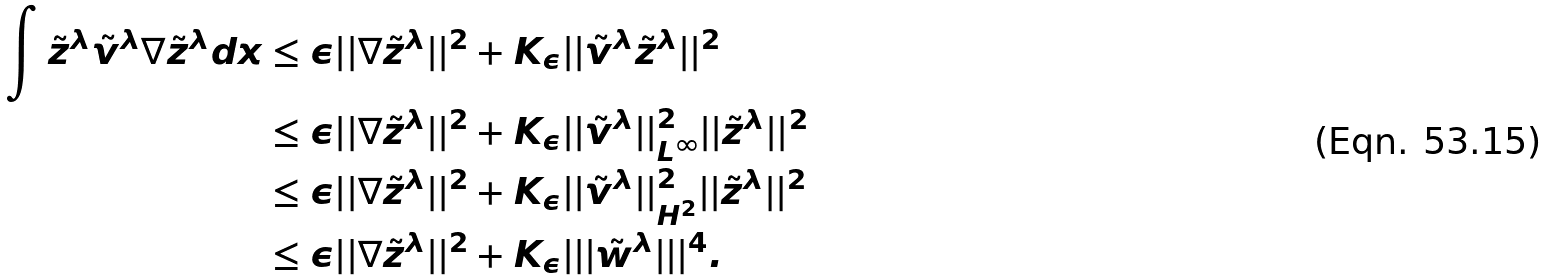<formula> <loc_0><loc_0><loc_500><loc_500>\int \tilde { z } ^ { \lambda } \tilde { v } ^ { \lambda } \nabla \tilde { z } ^ { \lambda } d x & \leq \epsilon | | \nabla \tilde { z } ^ { \lambda } | | ^ { 2 } + K _ { \epsilon } | | \tilde { v } ^ { \lambda } \tilde { z } ^ { \lambda } | | ^ { 2 } \\ & \leq \epsilon | | \nabla \tilde { z } ^ { \lambda } | | ^ { 2 } + K _ { \epsilon } | | \tilde { v } ^ { \lambda } | | _ { L ^ { \infty } } ^ { 2 } | | \tilde { z } ^ { \lambda } | | ^ { 2 } \\ & \leq \epsilon | | \nabla \tilde { z } ^ { \lambda } | | ^ { 2 } + K _ { \epsilon } | | \tilde { v } ^ { \lambda } | | _ { H ^ { 2 } } ^ { 2 } | | \tilde { z } ^ { \lambda } | | ^ { 2 } \\ & \leq \epsilon | | \nabla \tilde { z } ^ { \lambda } | | ^ { 2 } + K _ { \epsilon } | | | \tilde { w } ^ { \lambda } | | | ^ { 4 } .</formula> 